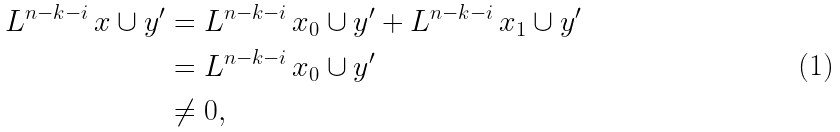Convert formula to latex. <formula><loc_0><loc_0><loc_500><loc_500>L ^ { n - k - i } \, x \cup y ^ { \prime } & = L ^ { n - k - i } \, x _ { 0 } \cup y ^ { \prime } + L ^ { n - k - i } \, x _ { 1 } \cup y ^ { \prime } \\ & = L ^ { n - k - i } \, x _ { 0 } \cup y ^ { \prime } \\ & \neq 0 ,</formula> 